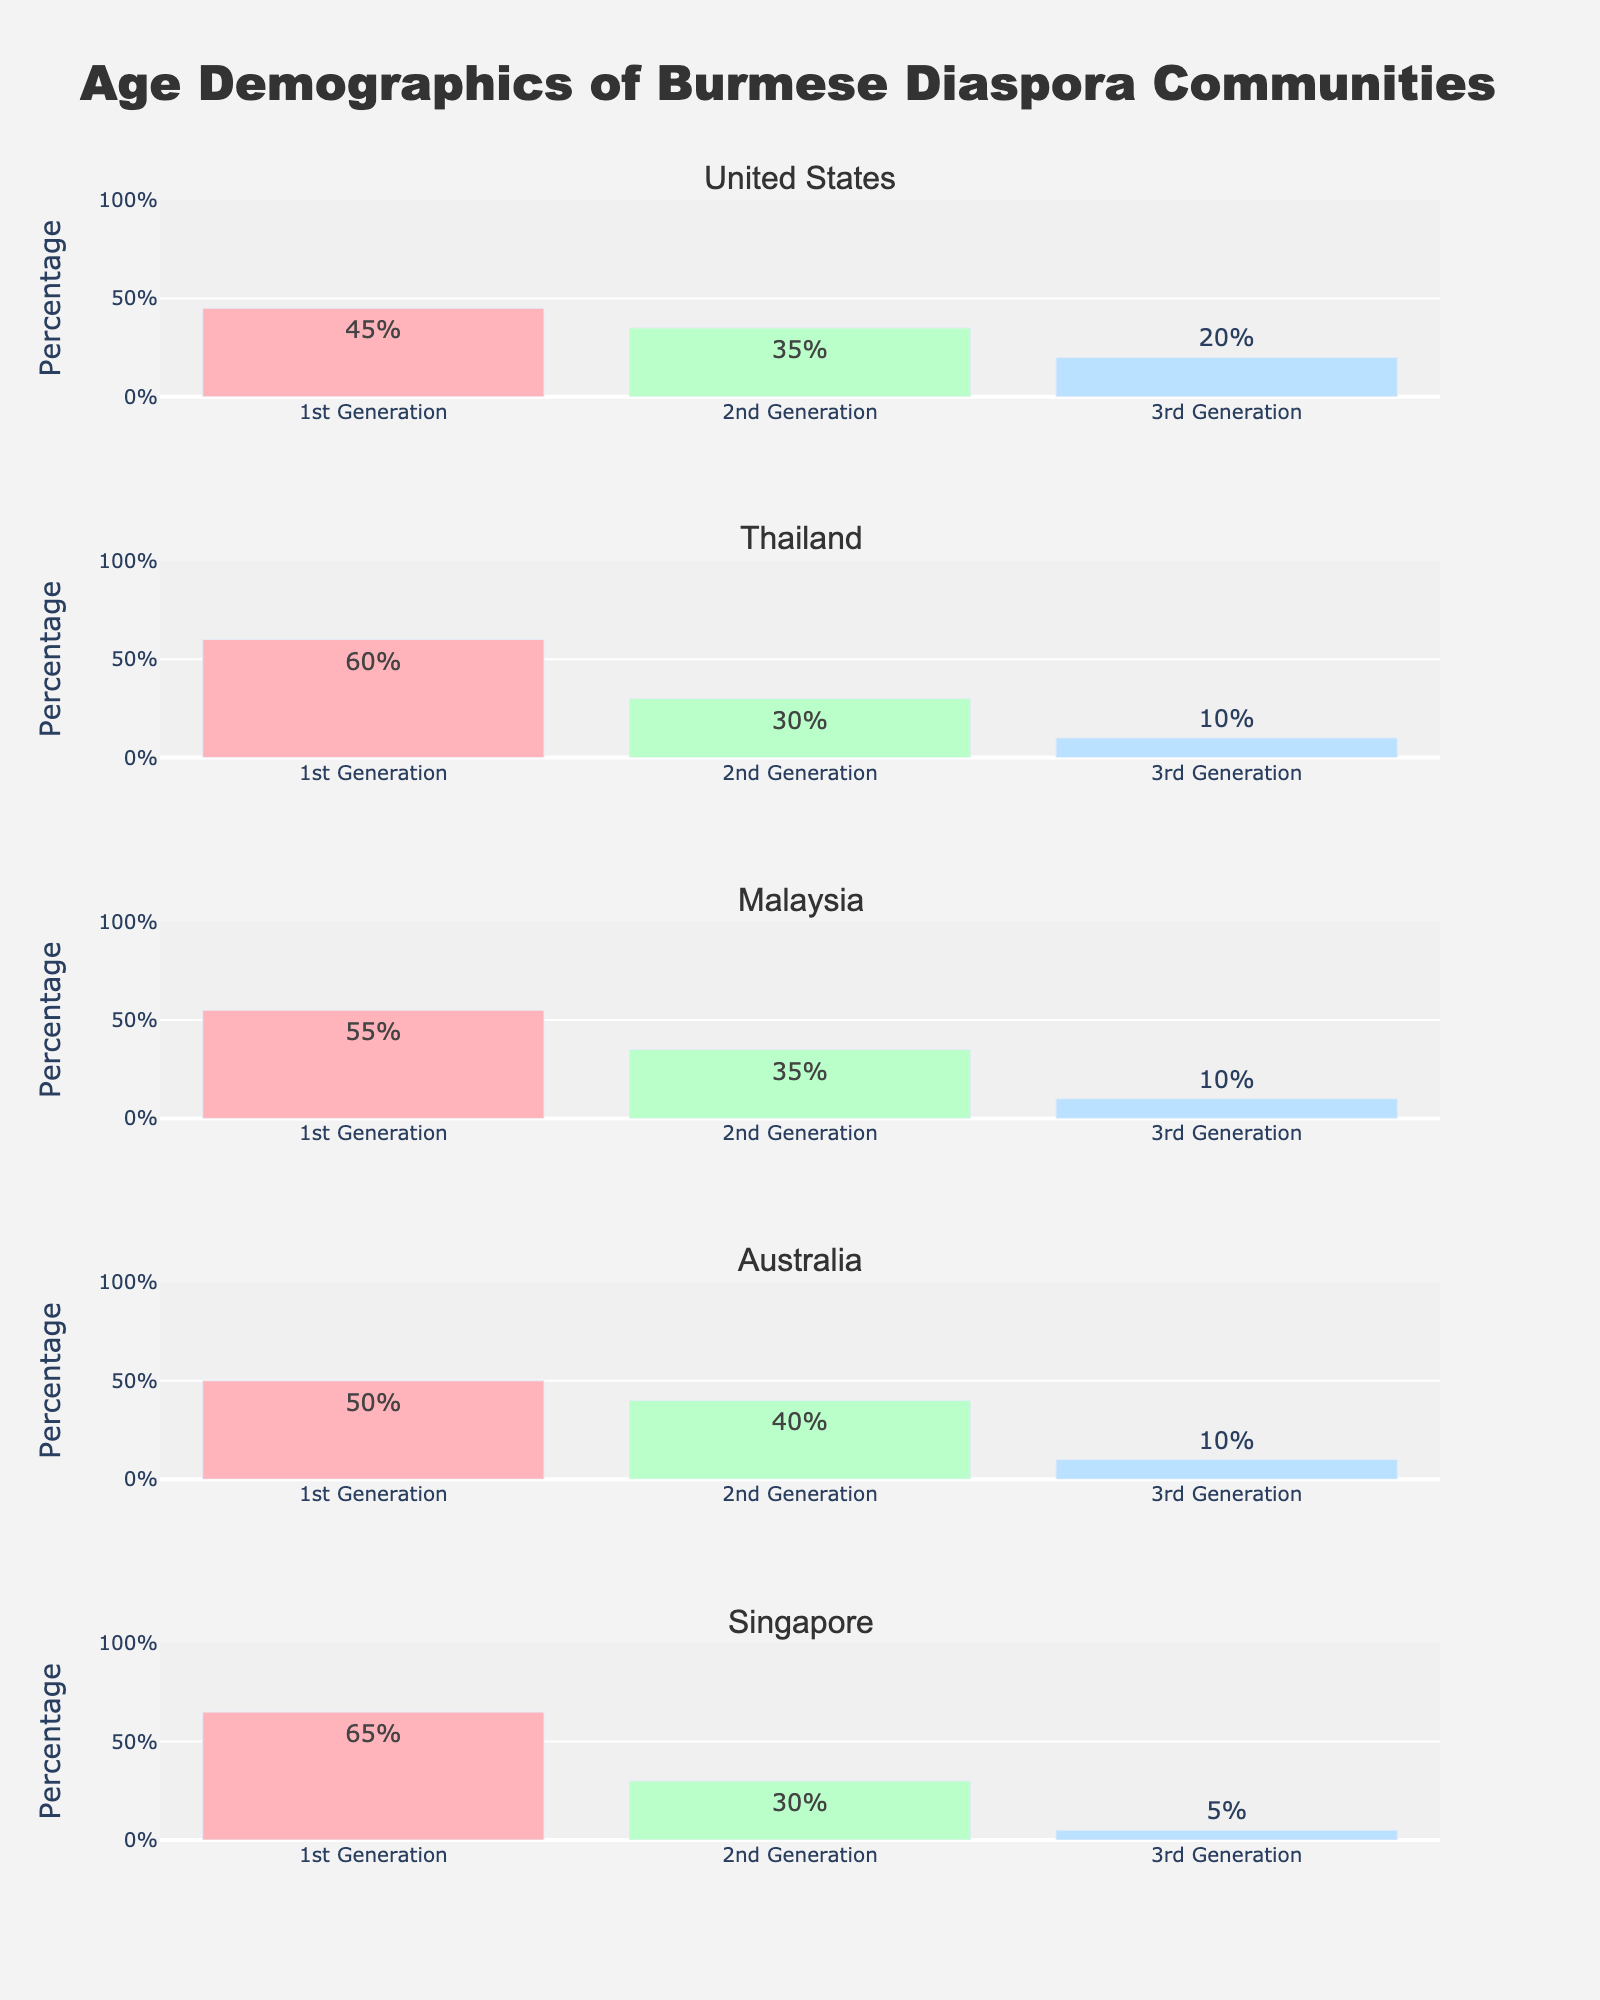Which country has the highest percentage of 1st generation Burmese diaspora? By looking at the vertical bars representing 1st generation across all countries, we see that Singapore has the tallest bar with 65%.
Answer: Singapore Which generation has the smallest percentage in Thailand? By examining the bars for Thailand, the 3rd generation has the smallest percentage, represented by the shortest bar at 10%.
Answer: 3rd Generation How does the percentage of 2nd generation Burmese in the United States compare to 2nd generation Burmese in Malaysia? The figure shows that the United States has 35% for the 2nd generation, and Malaysia also has 35%. So, these percentages are equal.
Answer: Equal What is the combined percentage of Burmese diaspora for all generations in Australia? Adding the percentages for the 1st, 2nd, and 3rd generations in Australia (50% + 40% + 10%), we get a total of 100%.
Answer: 100% Which generation has the most consistent percentage across the five countries? By comparing the heights of the bars for each generation across all countries, the 3rd generation appears to have consistently lower percentages (ranging from 5% to 20%).
Answer: 3rd Generation What is the average percentage of 2nd generation Burmese diaspora across all countries? Adding the percentages for the 2nd generation in all countries (35% + 30% + 35% + 40% + 30%) and dividing by 5, (35 + 30 + 35 + 40 + 30) / 5 = 34%.
Answer: 34% In which country do the 1st and 2nd generations combined make up less than 80% of the population? Summing the percentages for 1st and 2nd generations for each country, we see that the United States (45% + 35% = 80%) is the only one where they don’t sum to less than 80%. All other countries have less than 80%. So this question assumes the sum is less than 80%, which is not supported by the figure.
Answer: None How does the percentage of 3rd generation Burmese in Singapore compare to the 3rd generation in Australia? The figure shows that the percentage for Singapore's 3rd generation is 5% and for Australia's 3rd generation is 10%, making Australia's percentage higher than Singapore's.
Answer: Australia's percentage is higher 